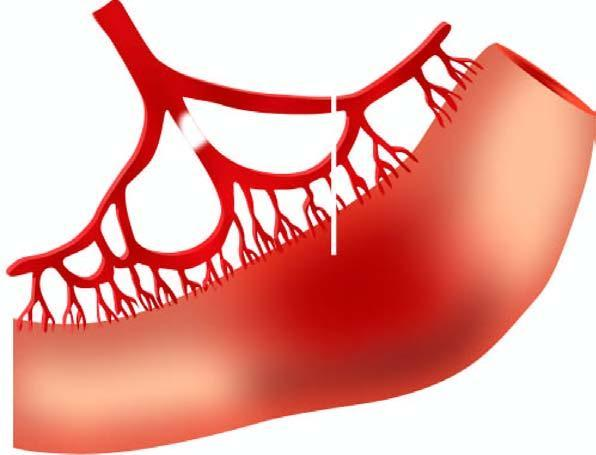what is soft, swollen and dark?
Answer the question using a single word or phrase. The affected part dark 